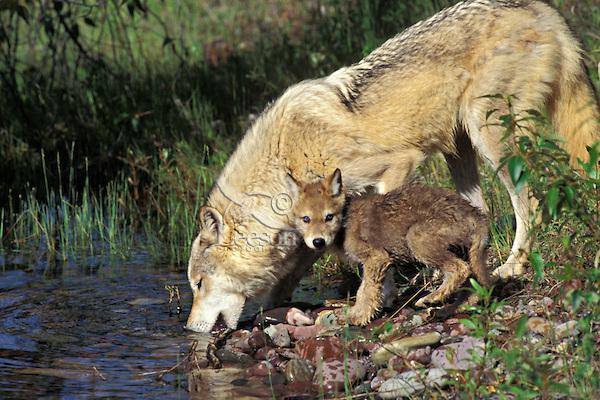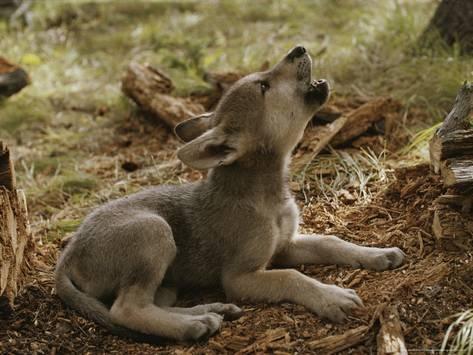The first image is the image on the left, the second image is the image on the right. Given the left and right images, does the statement "There is at least three wolves." hold true? Answer yes or no. Yes. The first image is the image on the left, the second image is the image on the right. For the images shown, is this caption "In one of the images, there are two young wolves." true? Answer yes or no. No. 